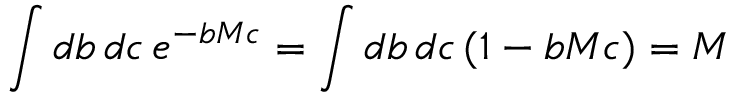<formula> <loc_0><loc_0><loc_500><loc_500>\int d b \, d c \, e ^ { - b M c } = \int d b \, d c \, ( 1 - b M c ) = M</formula> 